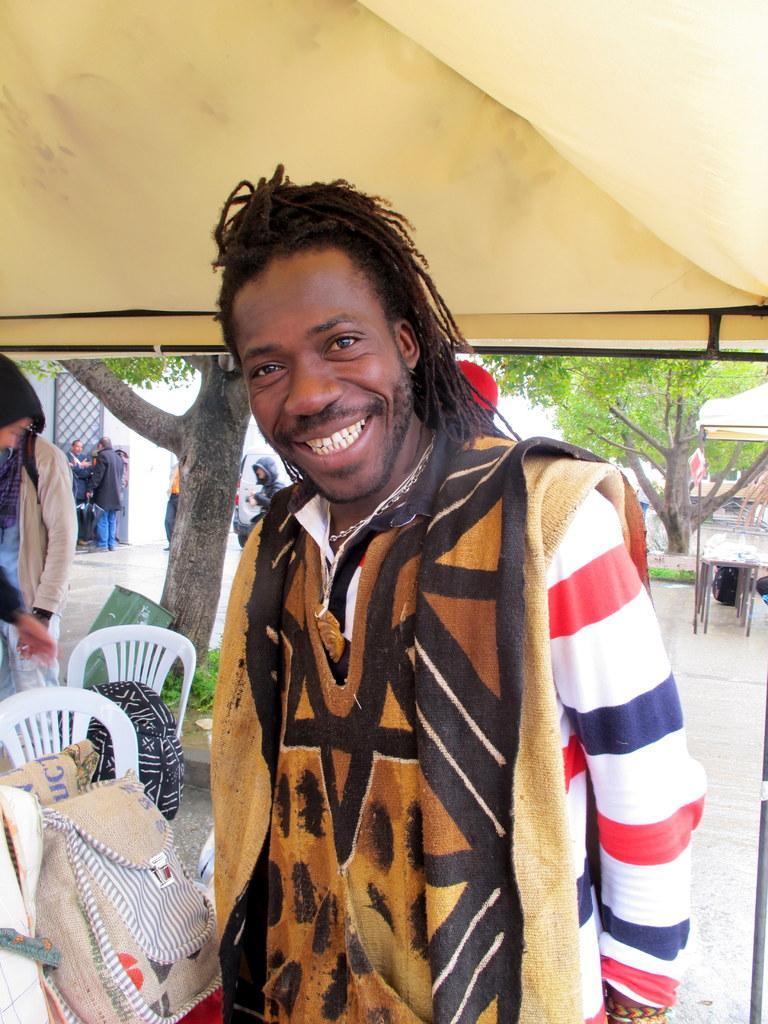Please provide a concise description of this image. In this picture I can see there is a man standing and he is smiling, he is wearing a coat and there are chairs behind him, there are few bags placed on the chairs and there is a tree in the backdrop, there are a few more people standing and there is another tree at the right side. 